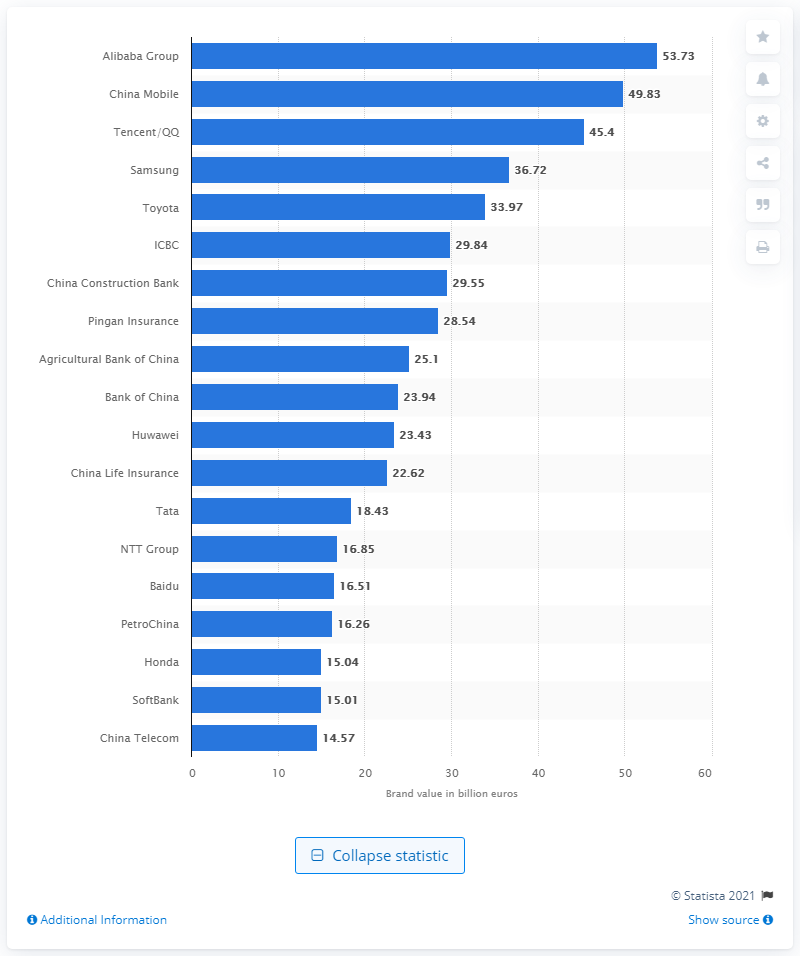Draw attention to some important aspects in this diagram. The second most valuable Asia Pacific corporate brand was China Mobile. In 2019, Alibaba Group's worth was approximately 53.73. In 2019, Alibaba Group was named the most valuable corporate brand in the Asia Pacific region. 